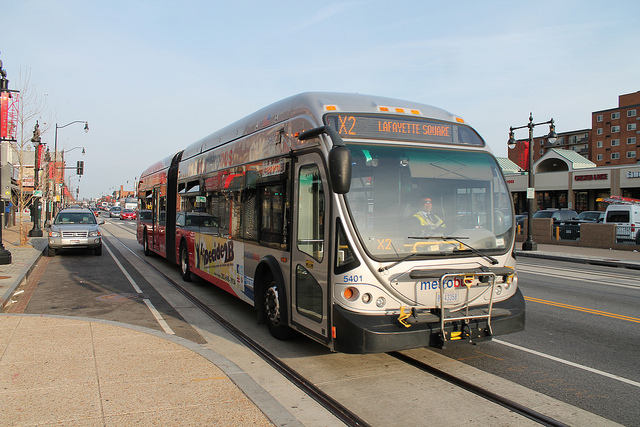What time of day does it seem to be in the photo? Based on the lighting and shadows in the image, it appears to be daytime, likely midday given the relatively short shadows, indicating the sun is quite high in the sky. What can we infer about the weather conditions? The clear skies and visibility in the image suggest that the weather is fair and probably sunny, conducive to outdoor activities and transportation. 